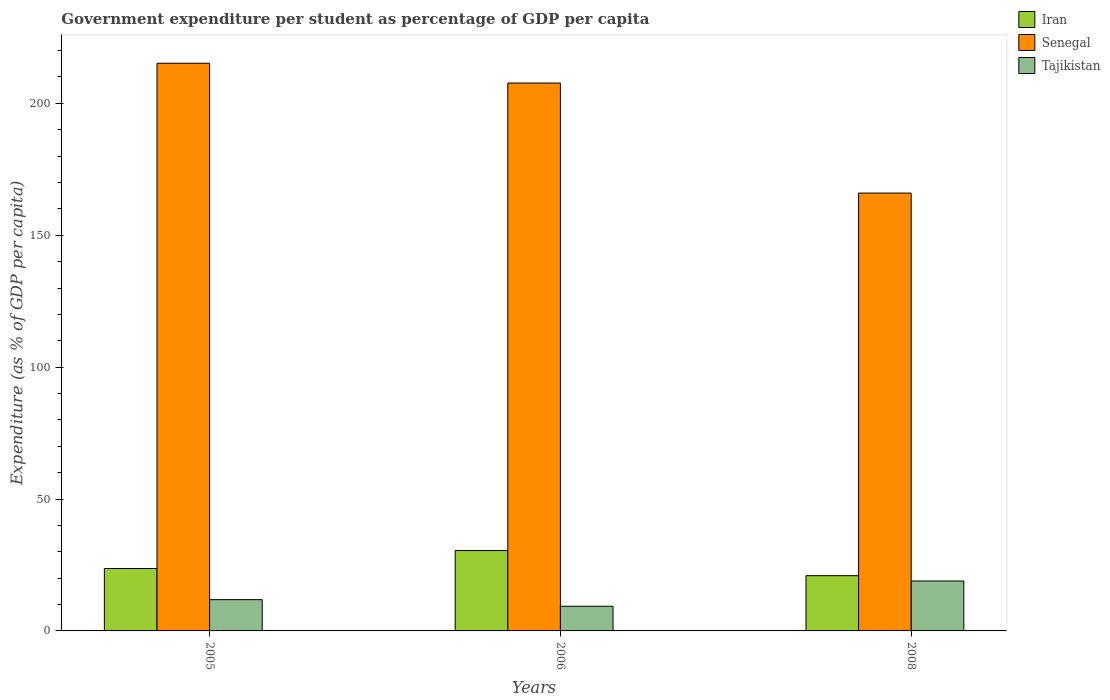How many bars are there on the 3rd tick from the left?
Make the answer very short. 3. What is the percentage of expenditure per student in Tajikistan in 2008?
Give a very brief answer. 18.93. Across all years, what is the maximum percentage of expenditure per student in Tajikistan?
Give a very brief answer. 18.93. Across all years, what is the minimum percentage of expenditure per student in Senegal?
Your answer should be compact. 166. In which year was the percentage of expenditure per student in Senegal maximum?
Your response must be concise. 2005. In which year was the percentage of expenditure per student in Tajikistan minimum?
Make the answer very short. 2006. What is the total percentage of expenditure per student in Senegal in the graph?
Offer a terse response. 588.92. What is the difference between the percentage of expenditure per student in Senegal in 2006 and that in 2008?
Offer a very short reply. 41.72. What is the difference between the percentage of expenditure per student in Iran in 2008 and the percentage of expenditure per student in Senegal in 2006?
Your response must be concise. -186.77. What is the average percentage of expenditure per student in Iran per year?
Your answer should be compact. 25.02. In the year 2008, what is the difference between the percentage of expenditure per student in Iran and percentage of expenditure per student in Senegal?
Your answer should be very brief. -145.05. In how many years, is the percentage of expenditure per student in Tajikistan greater than 110 %?
Offer a terse response. 0. What is the ratio of the percentage of expenditure per student in Senegal in 2005 to that in 2008?
Offer a very short reply. 1.3. Is the percentage of expenditure per student in Tajikistan in 2006 less than that in 2008?
Give a very brief answer. Yes. Is the difference between the percentage of expenditure per student in Iran in 2005 and 2008 greater than the difference between the percentage of expenditure per student in Senegal in 2005 and 2008?
Ensure brevity in your answer.  No. What is the difference between the highest and the second highest percentage of expenditure per student in Tajikistan?
Provide a succinct answer. 7.07. What is the difference between the highest and the lowest percentage of expenditure per student in Iran?
Your answer should be compact. 9.53. In how many years, is the percentage of expenditure per student in Tajikistan greater than the average percentage of expenditure per student in Tajikistan taken over all years?
Offer a terse response. 1. Is the sum of the percentage of expenditure per student in Iran in 2006 and 2008 greater than the maximum percentage of expenditure per student in Senegal across all years?
Your answer should be very brief. No. What does the 3rd bar from the left in 2008 represents?
Your response must be concise. Tajikistan. What does the 2nd bar from the right in 2005 represents?
Offer a very short reply. Senegal. Is it the case that in every year, the sum of the percentage of expenditure per student in Tajikistan and percentage of expenditure per student in Senegal is greater than the percentage of expenditure per student in Iran?
Offer a very short reply. Yes. Are the values on the major ticks of Y-axis written in scientific E-notation?
Offer a terse response. No. Does the graph contain any zero values?
Offer a very short reply. No. Does the graph contain grids?
Make the answer very short. No. Where does the legend appear in the graph?
Offer a terse response. Top right. How are the legend labels stacked?
Provide a succinct answer. Vertical. What is the title of the graph?
Your answer should be very brief. Government expenditure per student as percentage of GDP per capita. Does "Bulgaria" appear as one of the legend labels in the graph?
Offer a terse response. No. What is the label or title of the X-axis?
Keep it short and to the point. Years. What is the label or title of the Y-axis?
Your answer should be compact. Expenditure (as % of GDP per capita). What is the Expenditure (as % of GDP per capita) in Iran in 2005?
Your answer should be compact. 23.66. What is the Expenditure (as % of GDP per capita) in Senegal in 2005?
Offer a very short reply. 215.21. What is the Expenditure (as % of GDP per capita) of Tajikistan in 2005?
Your response must be concise. 11.86. What is the Expenditure (as % of GDP per capita) in Iran in 2006?
Provide a succinct answer. 30.47. What is the Expenditure (as % of GDP per capita) in Senegal in 2006?
Your answer should be very brief. 207.71. What is the Expenditure (as % of GDP per capita) of Tajikistan in 2006?
Offer a very short reply. 9.36. What is the Expenditure (as % of GDP per capita) in Iran in 2008?
Your response must be concise. 20.95. What is the Expenditure (as % of GDP per capita) in Senegal in 2008?
Make the answer very short. 166. What is the Expenditure (as % of GDP per capita) of Tajikistan in 2008?
Ensure brevity in your answer.  18.93. Across all years, what is the maximum Expenditure (as % of GDP per capita) of Iran?
Give a very brief answer. 30.47. Across all years, what is the maximum Expenditure (as % of GDP per capita) in Senegal?
Your answer should be very brief. 215.21. Across all years, what is the maximum Expenditure (as % of GDP per capita) in Tajikistan?
Your response must be concise. 18.93. Across all years, what is the minimum Expenditure (as % of GDP per capita) in Iran?
Your response must be concise. 20.95. Across all years, what is the minimum Expenditure (as % of GDP per capita) in Senegal?
Ensure brevity in your answer.  166. Across all years, what is the minimum Expenditure (as % of GDP per capita) of Tajikistan?
Ensure brevity in your answer.  9.36. What is the total Expenditure (as % of GDP per capita) of Iran in the graph?
Give a very brief answer. 75.07. What is the total Expenditure (as % of GDP per capita) of Senegal in the graph?
Ensure brevity in your answer.  588.92. What is the total Expenditure (as % of GDP per capita) in Tajikistan in the graph?
Provide a short and direct response. 40.15. What is the difference between the Expenditure (as % of GDP per capita) in Iran in 2005 and that in 2006?
Give a very brief answer. -6.82. What is the difference between the Expenditure (as % of GDP per capita) in Senegal in 2005 and that in 2006?
Keep it short and to the point. 7.5. What is the difference between the Expenditure (as % of GDP per capita) in Tajikistan in 2005 and that in 2006?
Make the answer very short. 2.5. What is the difference between the Expenditure (as % of GDP per capita) in Iran in 2005 and that in 2008?
Ensure brevity in your answer.  2.71. What is the difference between the Expenditure (as % of GDP per capita) of Senegal in 2005 and that in 2008?
Offer a terse response. 49.21. What is the difference between the Expenditure (as % of GDP per capita) in Tajikistan in 2005 and that in 2008?
Give a very brief answer. -7.07. What is the difference between the Expenditure (as % of GDP per capita) in Iran in 2006 and that in 2008?
Provide a succinct answer. 9.53. What is the difference between the Expenditure (as % of GDP per capita) of Senegal in 2006 and that in 2008?
Your answer should be very brief. 41.72. What is the difference between the Expenditure (as % of GDP per capita) of Tajikistan in 2006 and that in 2008?
Make the answer very short. -9.57. What is the difference between the Expenditure (as % of GDP per capita) in Iran in 2005 and the Expenditure (as % of GDP per capita) in Senegal in 2006?
Give a very brief answer. -184.06. What is the difference between the Expenditure (as % of GDP per capita) of Iran in 2005 and the Expenditure (as % of GDP per capita) of Tajikistan in 2006?
Offer a terse response. 14.3. What is the difference between the Expenditure (as % of GDP per capita) of Senegal in 2005 and the Expenditure (as % of GDP per capita) of Tajikistan in 2006?
Make the answer very short. 205.85. What is the difference between the Expenditure (as % of GDP per capita) in Iran in 2005 and the Expenditure (as % of GDP per capita) in Senegal in 2008?
Your answer should be compact. -142.34. What is the difference between the Expenditure (as % of GDP per capita) of Iran in 2005 and the Expenditure (as % of GDP per capita) of Tajikistan in 2008?
Offer a terse response. 4.72. What is the difference between the Expenditure (as % of GDP per capita) of Senegal in 2005 and the Expenditure (as % of GDP per capita) of Tajikistan in 2008?
Provide a short and direct response. 196.28. What is the difference between the Expenditure (as % of GDP per capita) of Iran in 2006 and the Expenditure (as % of GDP per capita) of Senegal in 2008?
Ensure brevity in your answer.  -135.52. What is the difference between the Expenditure (as % of GDP per capita) of Iran in 2006 and the Expenditure (as % of GDP per capita) of Tajikistan in 2008?
Your answer should be very brief. 11.54. What is the difference between the Expenditure (as % of GDP per capita) in Senegal in 2006 and the Expenditure (as % of GDP per capita) in Tajikistan in 2008?
Offer a very short reply. 188.78. What is the average Expenditure (as % of GDP per capita) of Iran per year?
Provide a short and direct response. 25.02. What is the average Expenditure (as % of GDP per capita) of Senegal per year?
Your answer should be very brief. 196.31. What is the average Expenditure (as % of GDP per capita) in Tajikistan per year?
Make the answer very short. 13.38. In the year 2005, what is the difference between the Expenditure (as % of GDP per capita) in Iran and Expenditure (as % of GDP per capita) in Senegal?
Your answer should be compact. -191.55. In the year 2005, what is the difference between the Expenditure (as % of GDP per capita) in Iran and Expenditure (as % of GDP per capita) in Tajikistan?
Give a very brief answer. 11.8. In the year 2005, what is the difference between the Expenditure (as % of GDP per capita) in Senegal and Expenditure (as % of GDP per capita) in Tajikistan?
Keep it short and to the point. 203.35. In the year 2006, what is the difference between the Expenditure (as % of GDP per capita) in Iran and Expenditure (as % of GDP per capita) in Senegal?
Give a very brief answer. -177.24. In the year 2006, what is the difference between the Expenditure (as % of GDP per capita) of Iran and Expenditure (as % of GDP per capita) of Tajikistan?
Keep it short and to the point. 21.11. In the year 2006, what is the difference between the Expenditure (as % of GDP per capita) in Senegal and Expenditure (as % of GDP per capita) in Tajikistan?
Provide a short and direct response. 198.35. In the year 2008, what is the difference between the Expenditure (as % of GDP per capita) of Iran and Expenditure (as % of GDP per capita) of Senegal?
Keep it short and to the point. -145.05. In the year 2008, what is the difference between the Expenditure (as % of GDP per capita) of Iran and Expenditure (as % of GDP per capita) of Tajikistan?
Provide a short and direct response. 2.01. In the year 2008, what is the difference between the Expenditure (as % of GDP per capita) of Senegal and Expenditure (as % of GDP per capita) of Tajikistan?
Provide a succinct answer. 147.06. What is the ratio of the Expenditure (as % of GDP per capita) in Iran in 2005 to that in 2006?
Your response must be concise. 0.78. What is the ratio of the Expenditure (as % of GDP per capita) of Senegal in 2005 to that in 2006?
Offer a terse response. 1.04. What is the ratio of the Expenditure (as % of GDP per capita) of Tajikistan in 2005 to that in 2006?
Ensure brevity in your answer.  1.27. What is the ratio of the Expenditure (as % of GDP per capita) of Iran in 2005 to that in 2008?
Provide a succinct answer. 1.13. What is the ratio of the Expenditure (as % of GDP per capita) in Senegal in 2005 to that in 2008?
Offer a very short reply. 1.3. What is the ratio of the Expenditure (as % of GDP per capita) in Tajikistan in 2005 to that in 2008?
Give a very brief answer. 0.63. What is the ratio of the Expenditure (as % of GDP per capita) in Iran in 2006 to that in 2008?
Make the answer very short. 1.45. What is the ratio of the Expenditure (as % of GDP per capita) in Senegal in 2006 to that in 2008?
Your answer should be very brief. 1.25. What is the ratio of the Expenditure (as % of GDP per capita) of Tajikistan in 2006 to that in 2008?
Provide a short and direct response. 0.49. What is the difference between the highest and the second highest Expenditure (as % of GDP per capita) in Iran?
Provide a succinct answer. 6.82. What is the difference between the highest and the second highest Expenditure (as % of GDP per capita) of Senegal?
Your response must be concise. 7.5. What is the difference between the highest and the second highest Expenditure (as % of GDP per capita) in Tajikistan?
Your answer should be compact. 7.07. What is the difference between the highest and the lowest Expenditure (as % of GDP per capita) of Iran?
Your answer should be very brief. 9.53. What is the difference between the highest and the lowest Expenditure (as % of GDP per capita) in Senegal?
Offer a terse response. 49.21. What is the difference between the highest and the lowest Expenditure (as % of GDP per capita) of Tajikistan?
Provide a succinct answer. 9.57. 